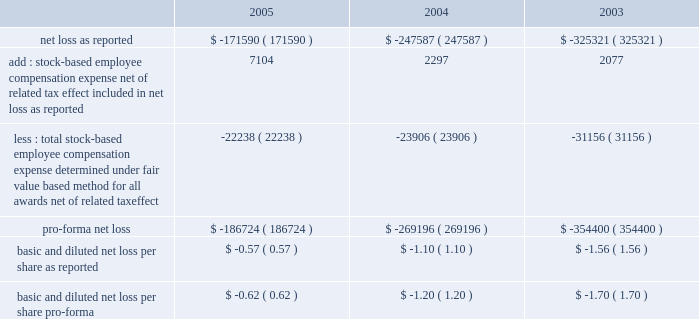American tower corporation and subsidiaries notes to consolidated financial statements 2014 ( continued ) sfas no .
148 .
In accordance with apb no .
25 , the company recognizes compensation expense based on the excess , if any , of the quoted stock price at the grant date of the award or other measurement date over the amount an employee must pay to acquire the stock .
The company 2019s stock option plans are more fully described in note 14 .
In december 2004 , the fasb issued sfas no .
123 ( revised 2004 ) , 201cshare-based payment 201d ( sfas 123r ) , as further described below .
During the year ended december 31 , 2005 , the company reevaluated the assumptions used to estimate the fair value of stock options issued to employees .
As a result , the company lowered its expected volatility assumption for options granted after july 1 , 2005 to approximately 30% ( 30 % ) and increased the expected life of option grants to 6.25 years using the simplified method permitted by sec sab no .
107 , 201dshare-based payment 201d ( sab no .
107 ) .
The company made this change based on a number of factors , including the company 2019s execution of its strategic plans to sell non-core businesses , reduce leverage and refinance its debt , and its recent merger with spectrasite , inc .
( see note 2. ) management had previously based its volatility assumptions on historical volatility since inception , which included periods when the company 2019s capital structure was more highly leveraged than current levels and expected levels for the foreseeable future .
Management 2019s estimate of future volatility is based on its consideration of all available information , including historical volatility , implied volatility of publicly traded options , the company 2019s current capital structure and its publicly announced future business plans .
For comparative purposes , a 10% ( 10 % ) change in the volatility assumption would change pro forma stock option expense and pro forma net loss by approximately $ 0.1 million for the year ended december 31 , 2005 .
( see note 14. ) the table illustrates the effect on net loss and net loss per common share if the company had applied the fair value recognition provisions of sfas no .
123 ( as amended ) to stock-based compensation .
The estimated fair value of each option is calculated using the black-scholes option-pricing model ( in thousands , except per share amounts ) : .
The company has modified certain option awards to revise vesting and exercise terms for certain terminated employees and recognized charges of $ 7.0 million , $ 3.0 million and $ 2.3 million for the years ended december 31 , 2005 , 2004 and 2003 , respectively .
In addition , the stock-based employee compensation amounts above for the year ended december 31 , 2005 , include approximately $ 2.4 million of unearned compensation amortization related to unvested stock options assumed in the merger with spectrasite , inc .
Such charges are reflected in impairments , net loss on sale of long-lived assets , restructuring and merger related expense with corresponding adjustments to additional paid-in capital and unearned compensation in the accompanying consolidated financial statements .
Recent accounting pronouncements 2014in december 2004 , the fasb issued sfas 123r , which supersedes apb no .
25 , and amends sfas no .
95 , 201cstatement of cash flows . 201d this statement addressed the accounting for share-based payments to employees , including grants of employee stock options .
Under the new standard .
What was the ratio of the recognized charges based on the modification of vesting and exercise terms for certain terminated for the year 2005 and 2004? 
Computations: (7 / 3)
Answer: 2.33333. 